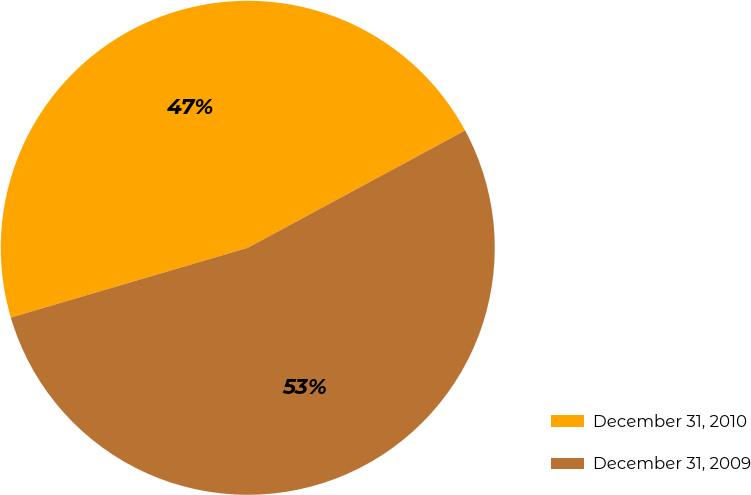Convert chart. <chart><loc_0><loc_0><loc_500><loc_500><pie_chart><fcel>December 31, 2010<fcel>December 31, 2009<nl><fcel>46.68%<fcel>53.32%<nl></chart> 